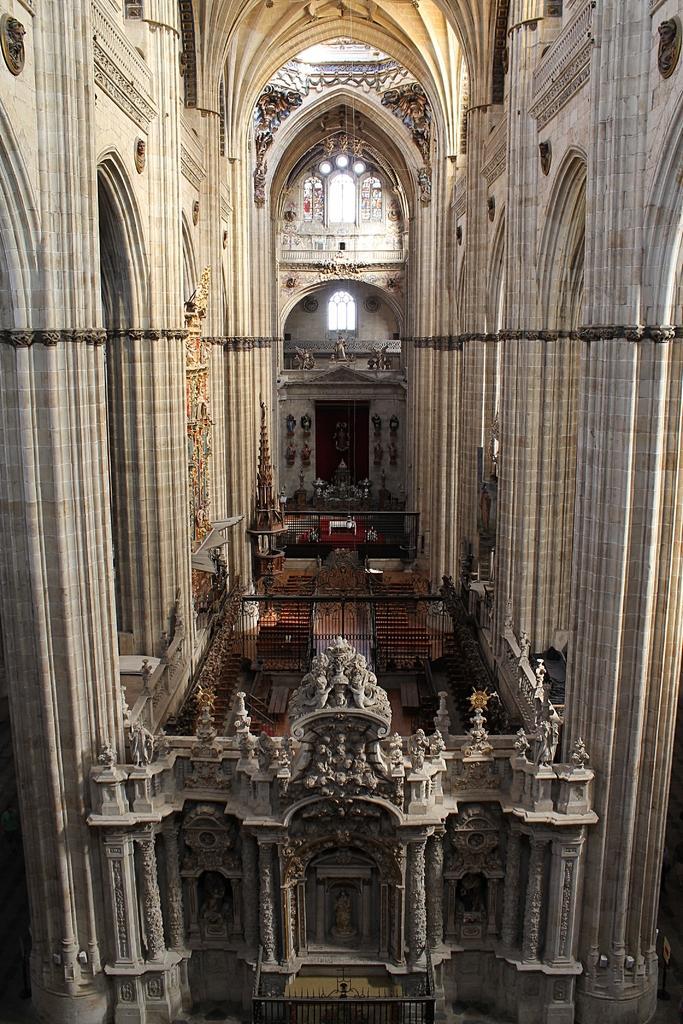Describe this image in one or two sentences. This image is taken in the hall. In this image we can see sculptures carved on the wall. There are pillars. There are grilles and we can see stained glasses. There is a door. 